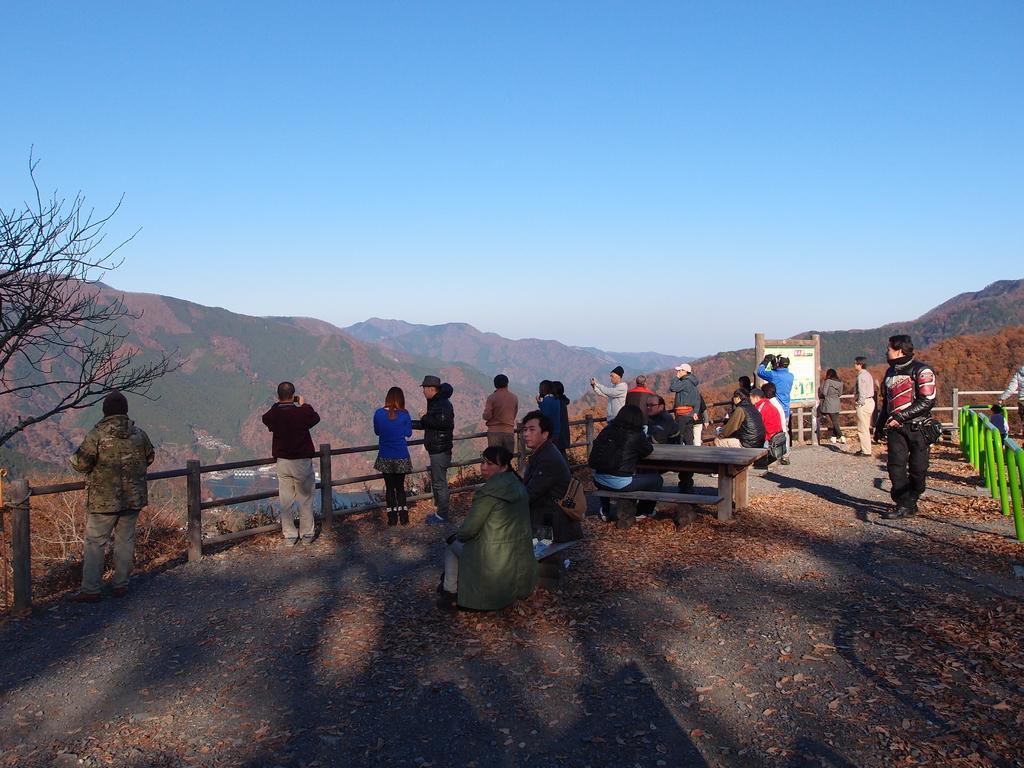In one or two sentences, can you explain what this image depicts? In this image I can see the group of people standing and two people are siting on the bench. There is a table in front of them. One person is wearing the bag. I can see a railing and a board in front of the standing people. To the right there is a green color railing. In the back there are mountains in the sky. 